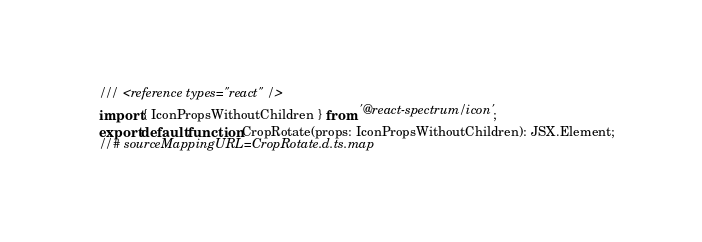<code> <loc_0><loc_0><loc_500><loc_500><_TypeScript_>/// <reference types="react" />
import { IconPropsWithoutChildren } from '@react-spectrum/icon';
export default function CropRotate(props: IconPropsWithoutChildren): JSX.Element;
//# sourceMappingURL=CropRotate.d.ts.map</code> 